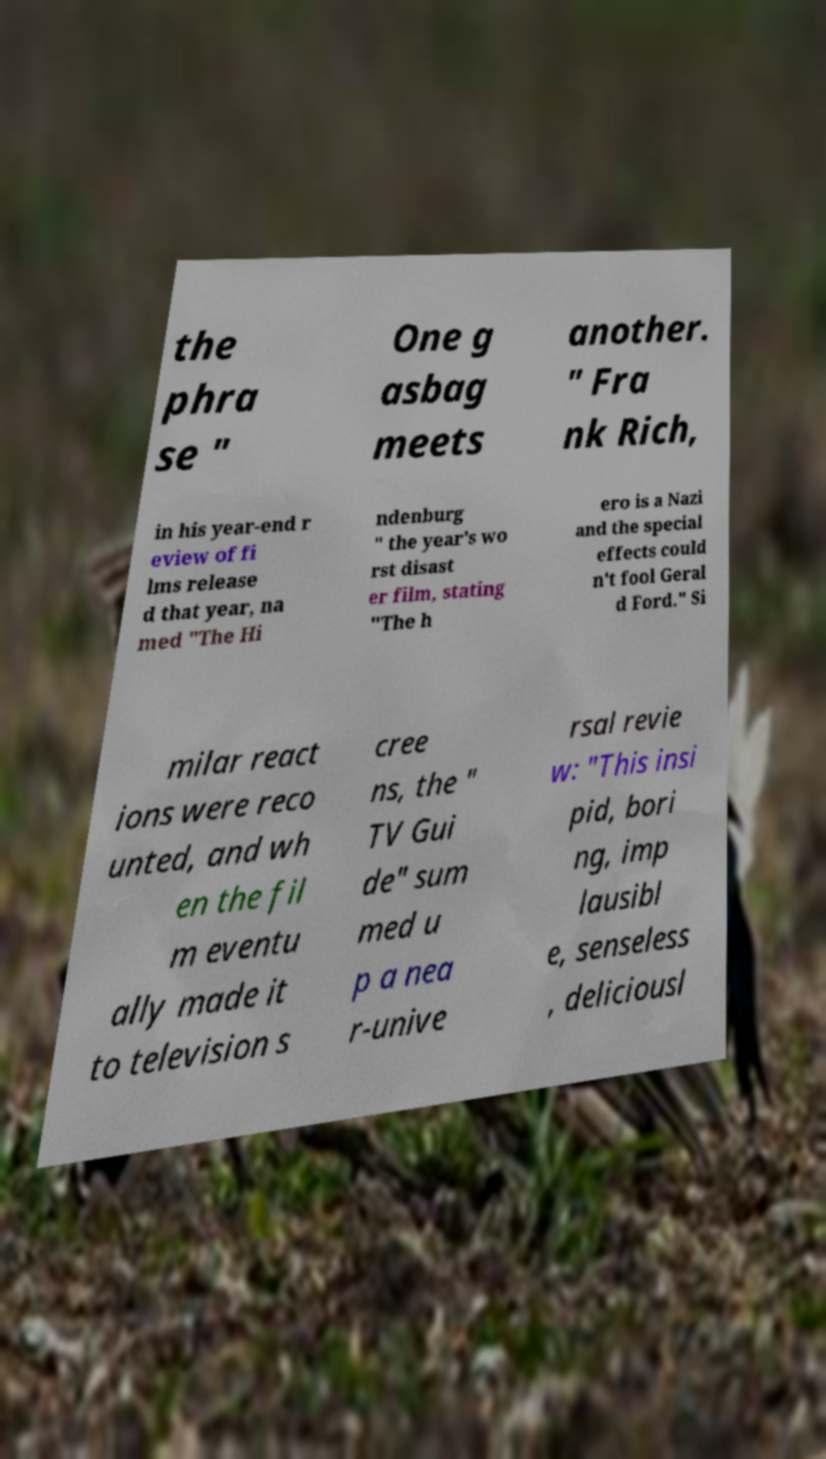Can you read and provide the text displayed in the image?This photo seems to have some interesting text. Can you extract and type it out for me? the phra se " One g asbag meets another. " Fra nk Rich, in his year-end r eview of fi lms release d that year, na med "The Hi ndenburg " the year's wo rst disast er film, stating "The h ero is a Nazi and the special effects could n't fool Geral d Ford." Si milar react ions were reco unted, and wh en the fil m eventu ally made it to television s cree ns, the " TV Gui de" sum med u p a nea r-unive rsal revie w: "This insi pid, bori ng, imp lausibl e, senseless , deliciousl 